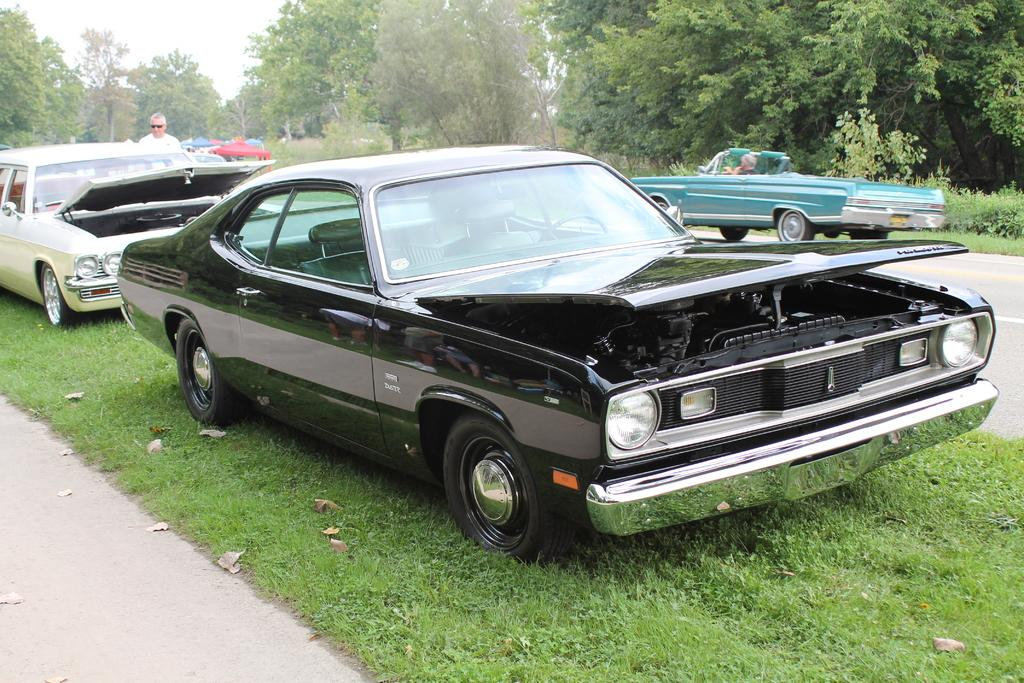What is placed on the grass in the image? There are cars placed on the grass in the image. Can you describe the person in the image? There is a person standing on the left side of the image. What can be seen in the background of the image? There is a group of trees and plants visible in the background of the image, as well as the sky. How many lizards are crawling on the person's legs in the image? There are no lizards present in the image, and the person's legs are not visible. What color is the hydrant next to the cars on the grass? There is no hydrant present in the image; only cars, a person, and vegetation are visible. 